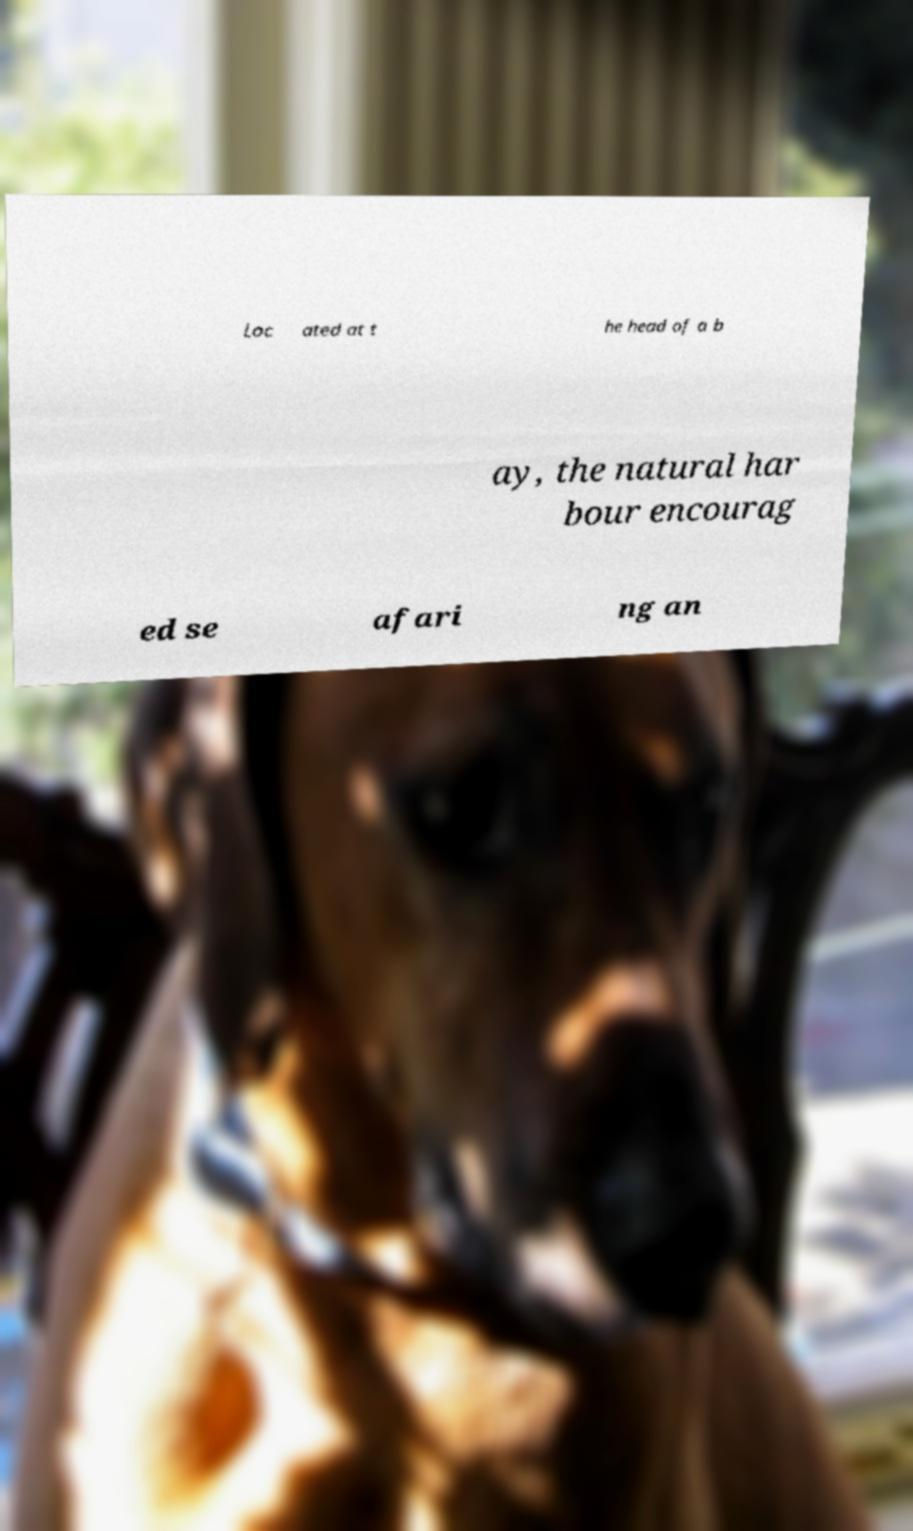Could you assist in decoding the text presented in this image and type it out clearly? Loc ated at t he head of a b ay, the natural har bour encourag ed se afari ng an 